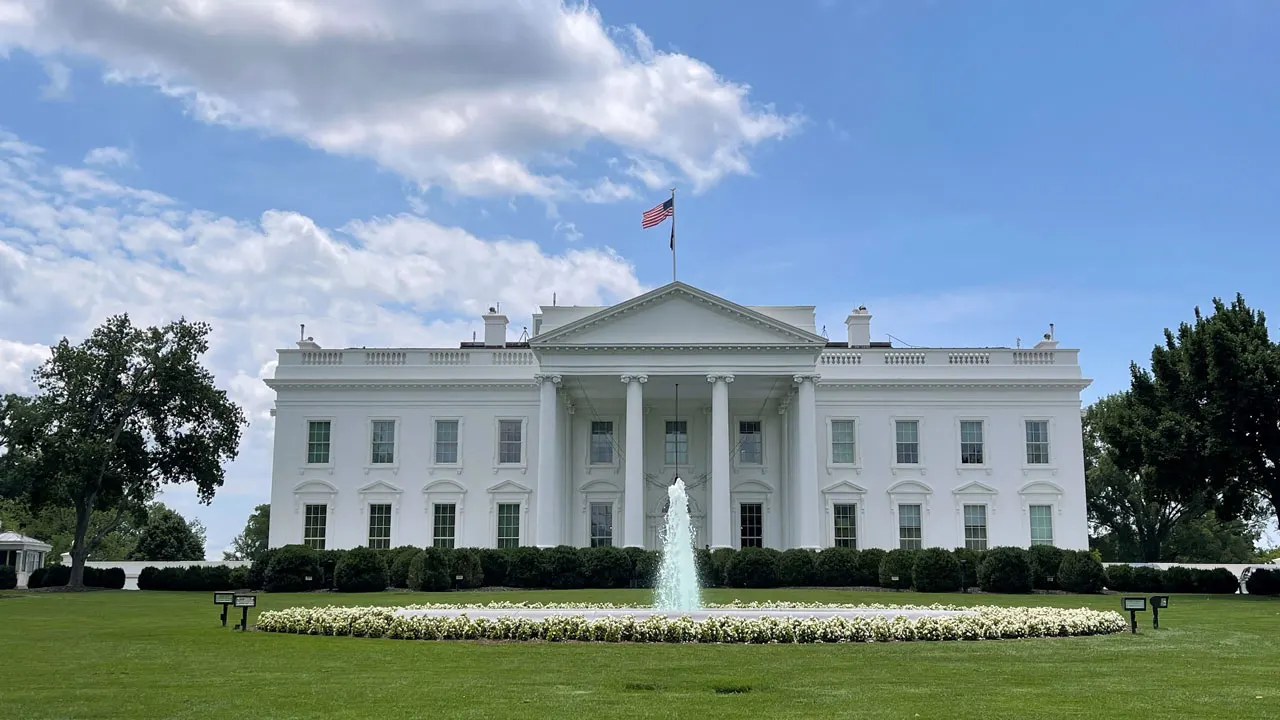What can you tell me about the history of the gardens and grounds surrounding the White House? The gardens and grounds of the White House have a rich history, evolving over the centuries to reflect the tastes and preferences of different presidents and their families. Originally designed by George Washington and Thomas Jefferson, the landscape has been shaped by various architects and horticulturists. The South Lawn, with its expansive open space and elegant fountain, serves as a venue for numerous events and ceremonies. The Rose Garden, established by First Lady Ellen Wilson and later redesigned by Jacqueline Kennedy and Melania Trump, is a beautiful formal garden used for important functions and speeches. Additionally, the Jacqueline Kennedy Garden and the Children's Garden offer tranquil areas for relaxation and enjoyment. The grounds also include historic trees and plantings, some of which date back to the 19th century, adding layers of natural beauty and historical significance to the surroundings. 